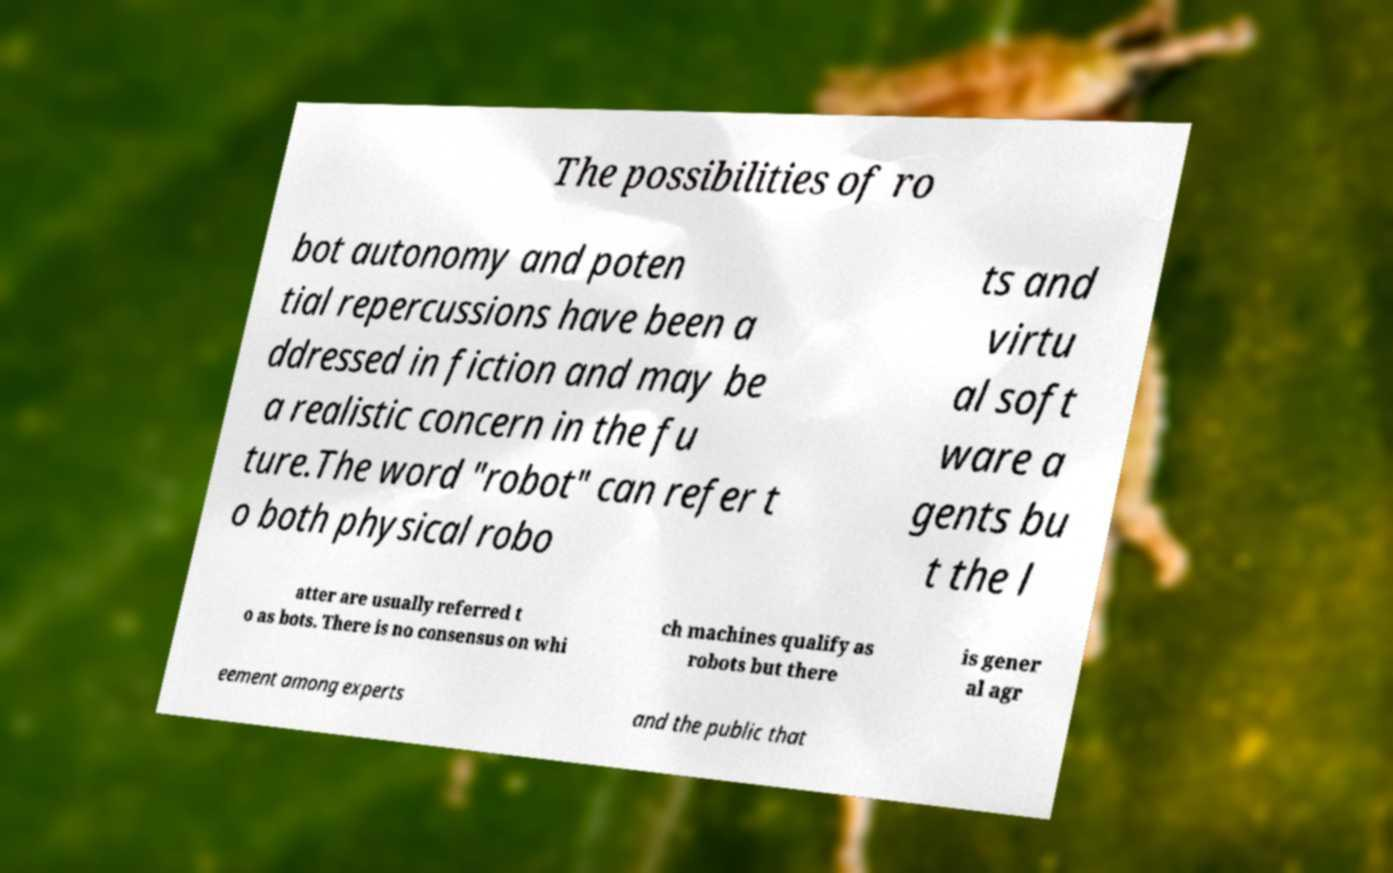There's text embedded in this image that I need extracted. Can you transcribe it verbatim? The possibilities of ro bot autonomy and poten tial repercussions have been a ddressed in fiction and may be a realistic concern in the fu ture.The word "robot" can refer t o both physical robo ts and virtu al soft ware a gents bu t the l atter are usually referred t o as bots. There is no consensus on whi ch machines qualify as robots but there is gener al agr eement among experts and the public that 